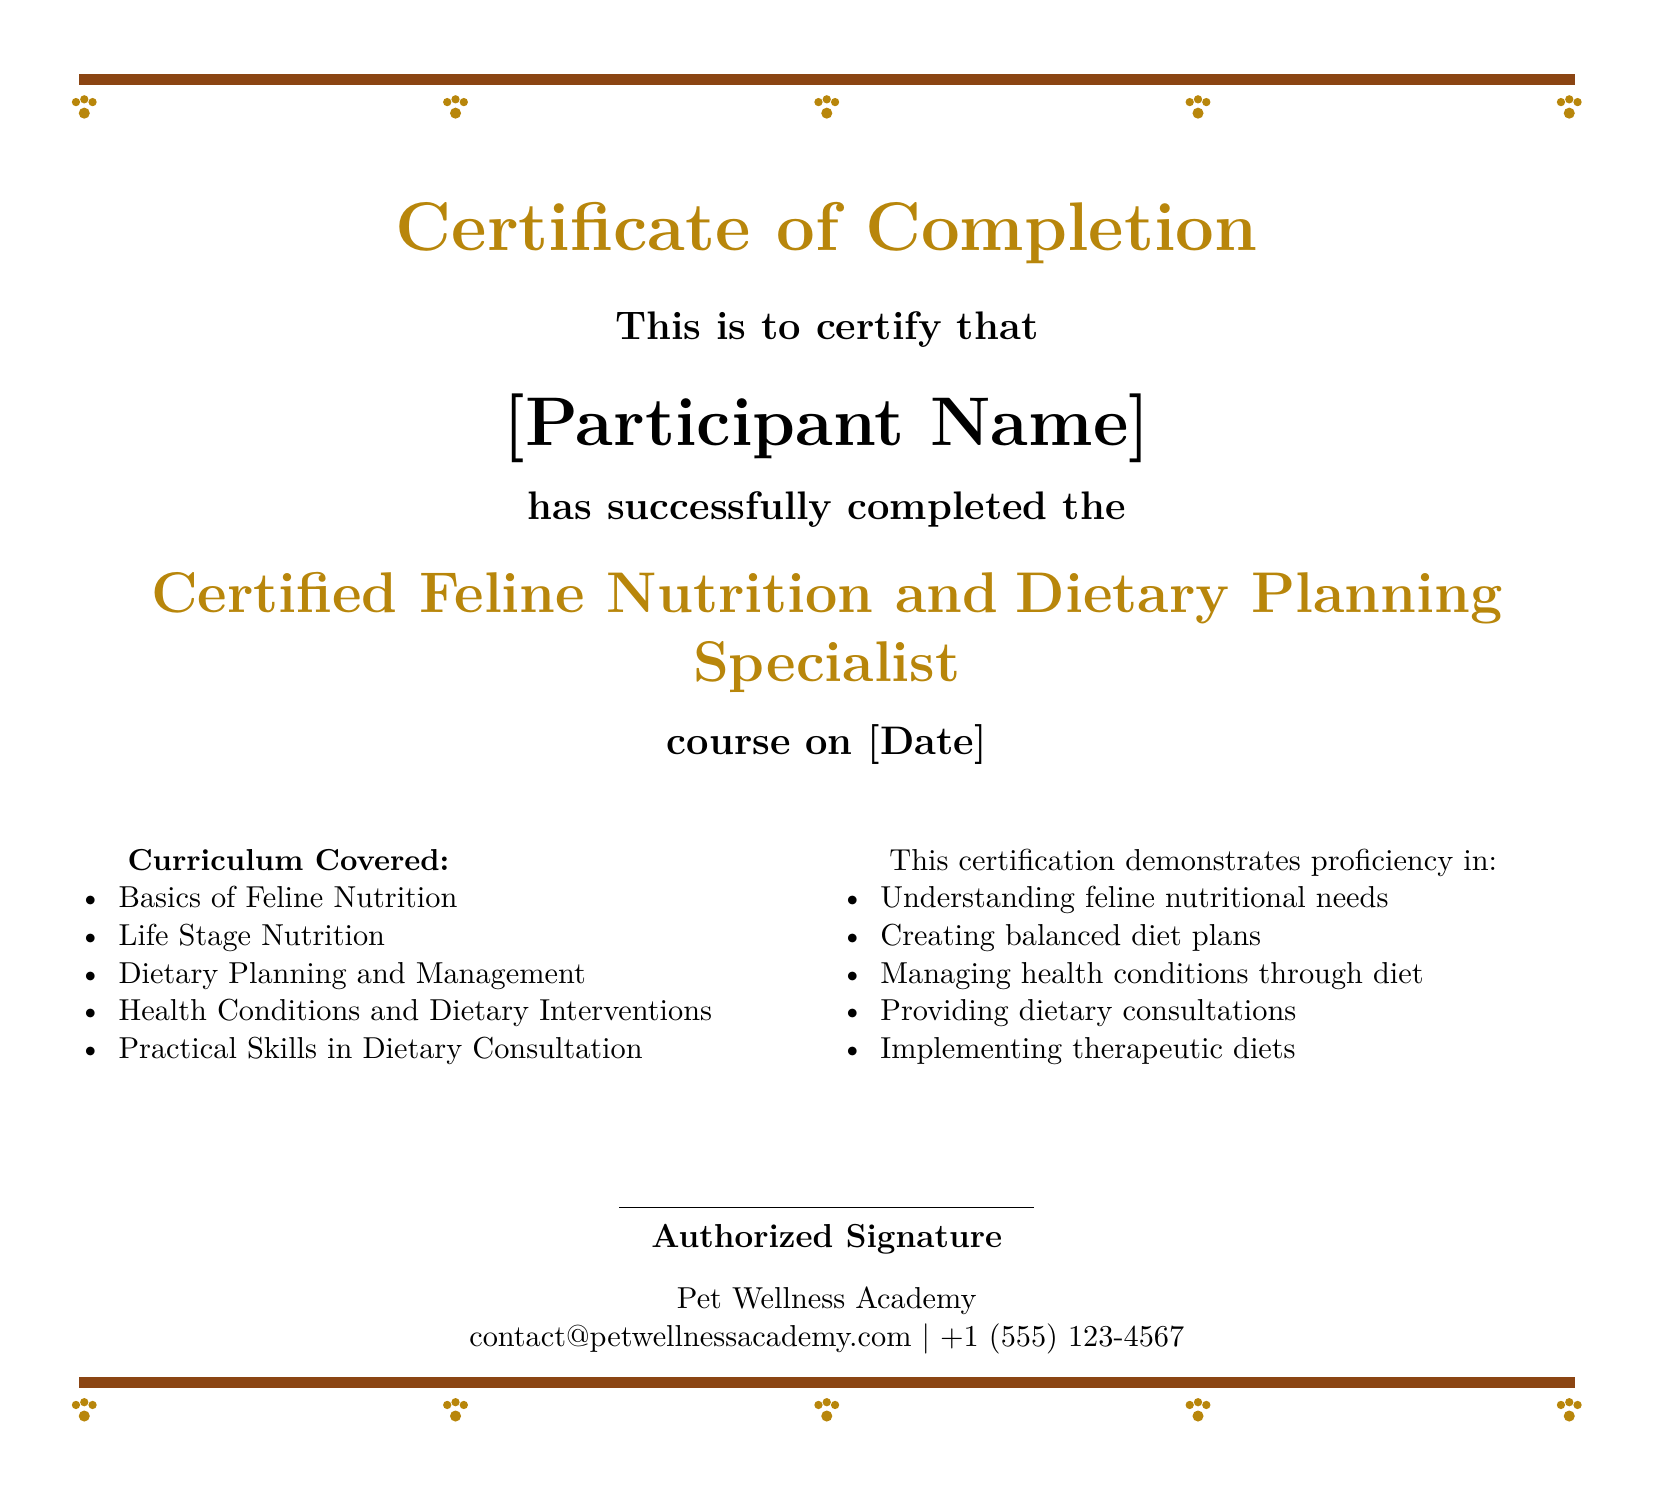What is the title of the course? The title of the course is stated as "Certified Feline Nutrition and Dietary Planning Specialist."
Answer: Certified Feline Nutrition and Dietary Planning Specialist Who is the issuer of the certificate? The issuer of the certificate is mentioned as "Pet Wellness Academy."
Answer: Pet Wellness Academy What is the completion date of the course? The completion date is indicated by “[Date],” which is a placeholder for the actual date.
Answer: [Date] Which health topic is addressed in the curriculum? The curriculum includes "Health Conditions and Dietary Interventions" as a specific health topic.
Answer: Health Conditions and Dietary Interventions What competency does this certification demonstrate? One competency outlined is "Understanding feline nutritional needs."
Answer: Understanding feline nutritional needs What type of skills are included in the practical skills section? The practical skills section mentions "Practical Skills in Dietary Consultation."
Answer: Practical Skills in Dietary Consultation How many total curriculum items are listed? The document lists a total of five items under the curriculum covered section.
Answer: 5 What is the contact number for the issuing organization? The contact number for Pet Wellness Academy is provided as "+1 (555) 123-4567."
Answer: +1 (555) 123-4567 What is required for a participant to obtain this certificate? A participant must successfully complete the course to obtain the certificate.
Answer: Successfully completed the course 